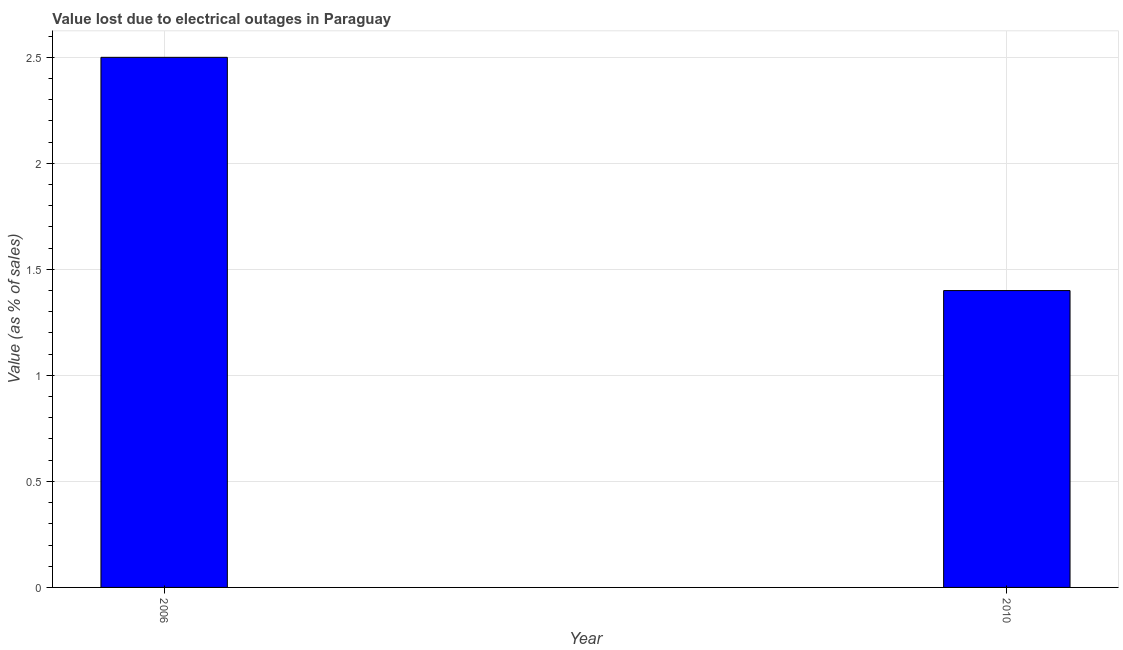What is the title of the graph?
Your answer should be very brief. Value lost due to electrical outages in Paraguay. What is the label or title of the Y-axis?
Your answer should be compact. Value (as % of sales). Across all years, what is the maximum value lost due to electrical outages?
Give a very brief answer. 2.5. Across all years, what is the minimum value lost due to electrical outages?
Keep it short and to the point. 1.4. In which year was the value lost due to electrical outages minimum?
Provide a short and direct response. 2010. What is the average value lost due to electrical outages per year?
Offer a very short reply. 1.95. What is the median value lost due to electrical outages?
Keep it short and to the point. 1.95. In how many years, is the value lost due to electrical outages greater than 0.3 %?
Keep it short and to the point. 2. Do a majority of the years between 2006 and 2010 (inclusive) have value lost due to electrical outages greater than 2.4 %?
Your answer should be very brief. No. What is the ratio of the value lost due to electrical outages in 2006 to that in 2010?
Ensure brevity in your answer.  1.79. Is the value lost due to electrical outages in 2006 less than that in 2010?
Make the answer very short. No. In how many years, is the value lost due to electrical outages greater than the average value lost due to electrical outages taken over all years?
Provide a succinct answer. 1. Are all the bars in the graph horizontal?
Give a very brief answer. No. What is the Value (as % of sales) of 2006?
Keep it short and to the point. 2.5. What is the Value (as % of sales) of 2010?
Offer a very short reply. 1.4. What is the difference between the Value (as % of sales) in 2006 and 2010?
Provide a succinct answer. 1.1. What is the ratio of the Value (as % of sales) in 2006 to that in 2010?
Your response must be concise. 1.79. 